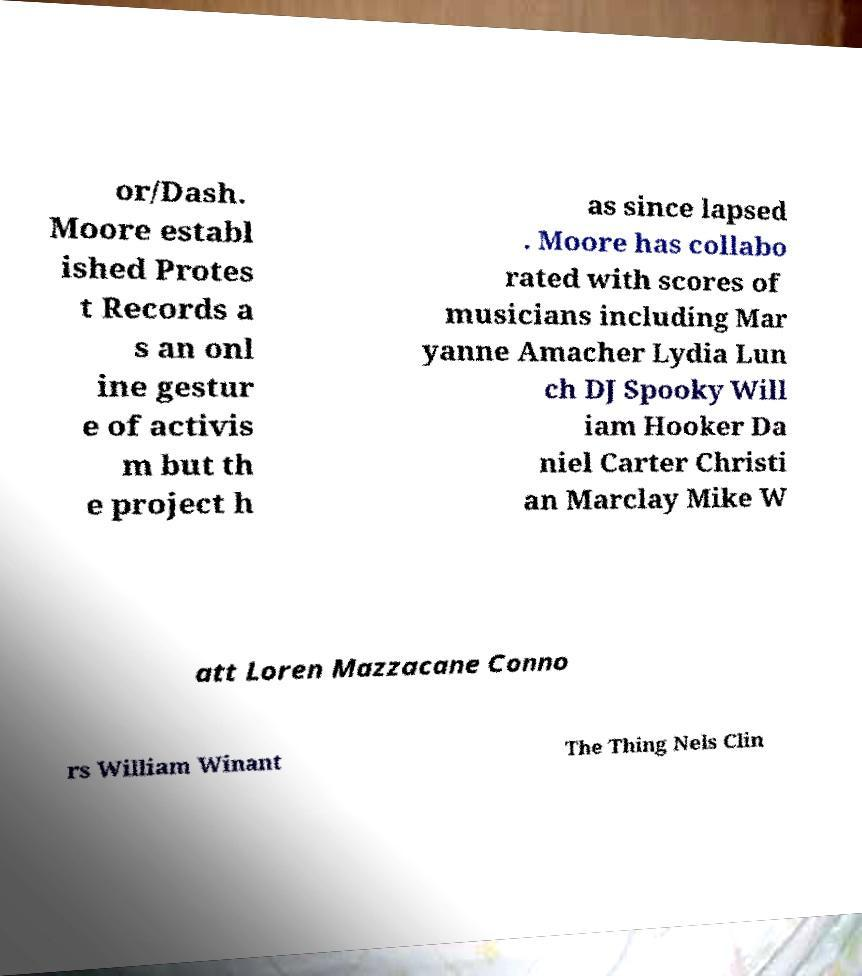Can you accurately transcribe the text from the provided image for me? or/Dash. Moore establ ished Protes t Records a s an onl ine gestur e of activis m but th e project h as since lapsed . Moore has collabo rated with scores of musicians including Mar yanne Amacher Lydia Lun ch DJ Spooky Will iam Hooker Da niel Carter Christi an Marclay Mike W att Loren Mazzacane Conno rs William Winant The Thing Nels Clin 